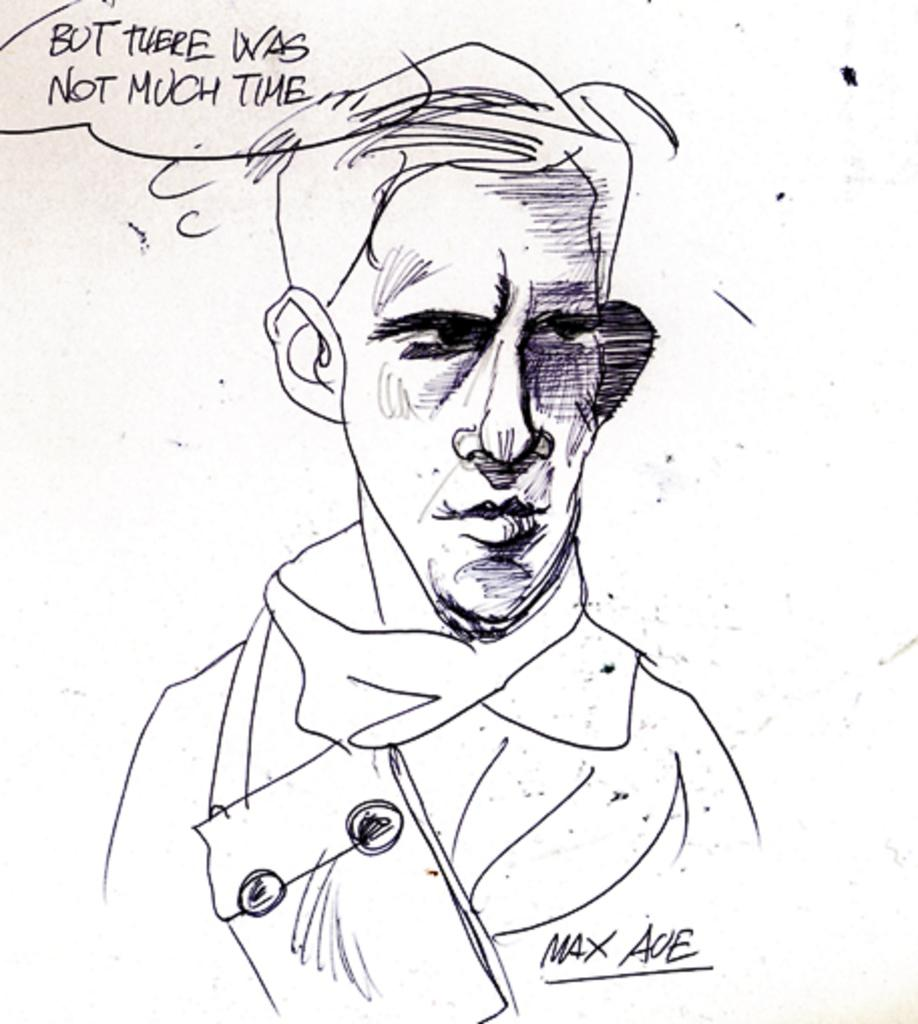What is depicted on the white paper in the image? There is a person's art on the white paper. What color is the art on the paper? The art is in black color. What text is written on the top of the paper? The text "but there was not much time" is written on the top of the paper. What type of coat is hanging in the garden in the image? There is no coat or garden present in the image; it only features a person's art on a white paper with black color and the text "but there was not much time." 